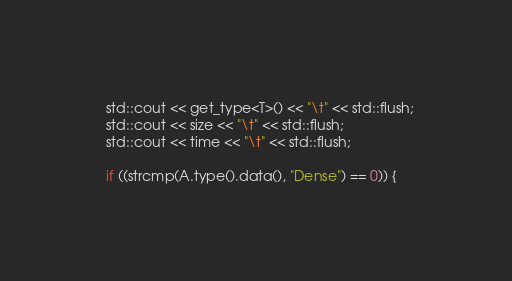<code> <loc_0><loc_0><loc_500><loc_500><_C++_>  std::cout << get_type<T>() << "\t" << std::flush;
  std::cout << size << "\t" << std::flush;
  std::cout << time << "\t" << std::flush;

  if ((strcmp(A.type().data(), "Dense") == 0)) {</code> 